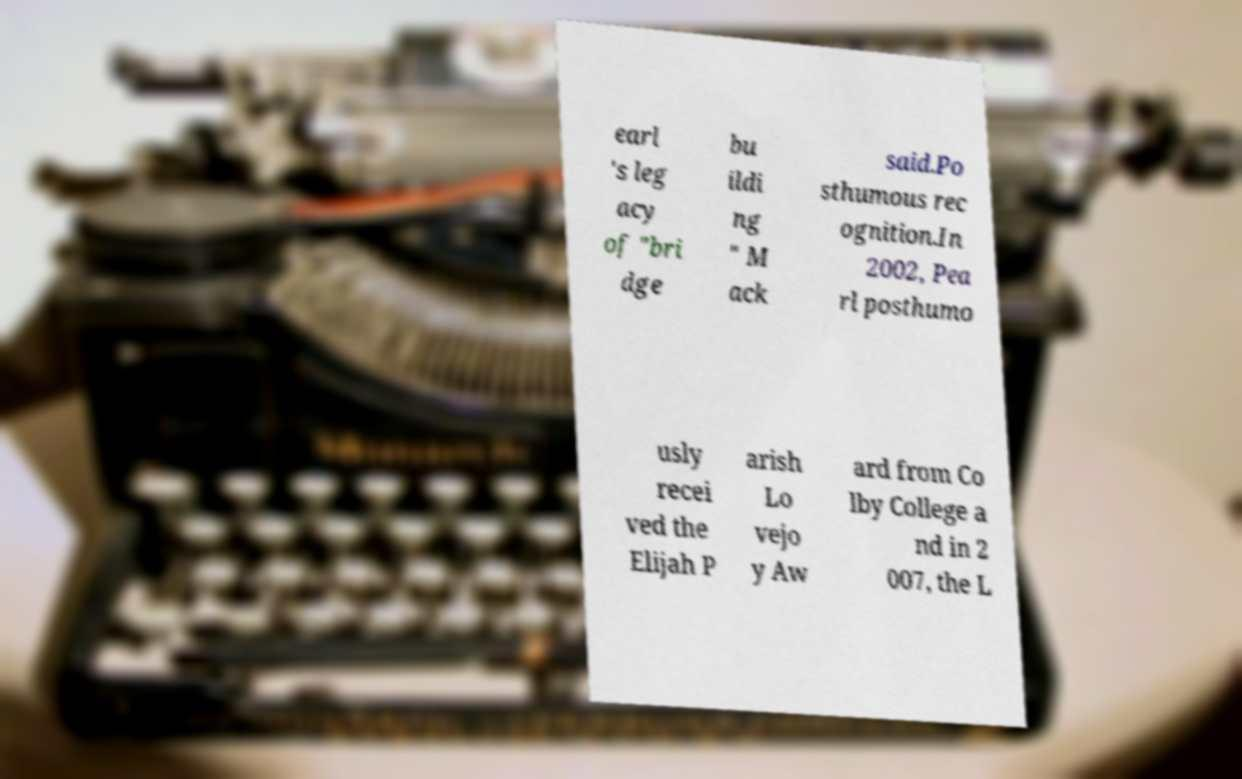Can you read and provide the text displayed in the image?This photo seems to have some interesting text. Can you extract and type it out for me? earl 's leg acy of "bri dge bu ildi ng " M ack said.Po sthumous rec ognition.In 2002, Pea rl posthumo usly recei ved the Elijah P arish Lo vejo y Aw ard from Co lby College a nd in 2 007, the L 